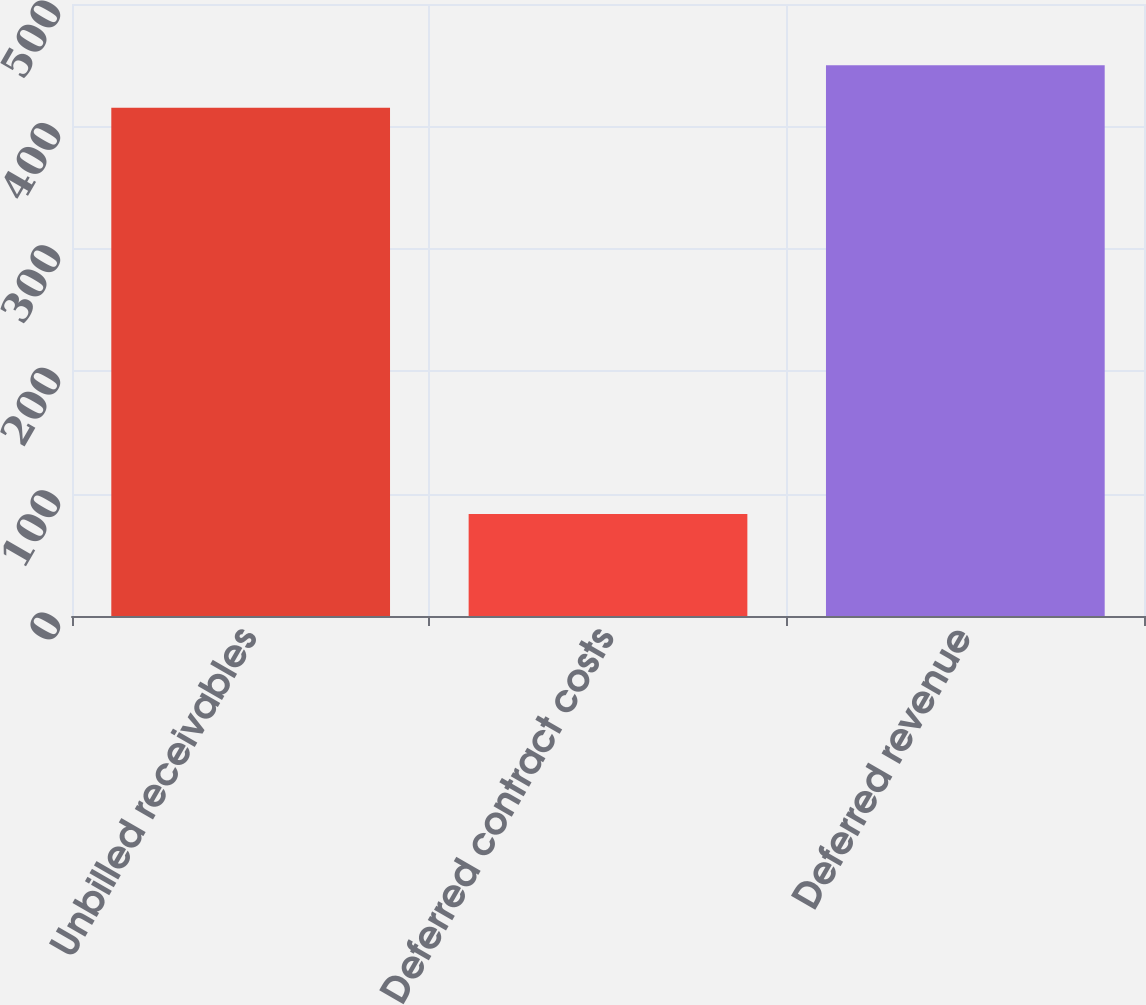<chart> <loc_0><loc_0><loc_500><loc_500><bar_chart><fcel>Unbilled receivables<fcel>Deferred contract costs<fcel>Deferred revenue<nl><fcel>415.2<fcel>83.3<fcel>449.93<nl></chart> 